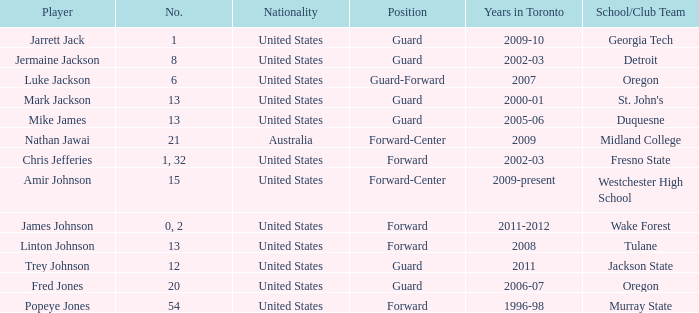What is the sum of positions on the toronto team during 2006-07? 1.0. 